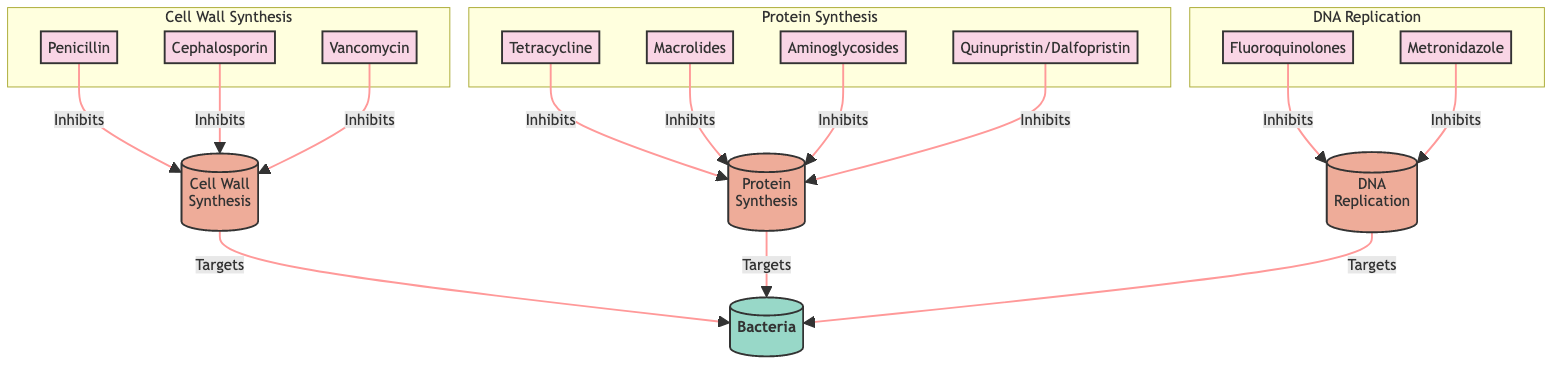What are the three main mechanisms of action illustrated in the diagram? The diagram displays three main mechanisms of action: Cell Wall Synthesis, Protein Synthesis, and DNA Replication. These are clearly labeled as subgraphs in the flowchart.
Answer: Cell Wall Synthesis, Protein Synthesis, DNA Replication How many antibiotics are associated with the Cell Wall Synthesis mechanism? The diagram shows three antibiotics related to Cell Wall Synthesis: Penicillin, Cephalosporin, and Vancomycin. Count the nodes connected to the Cell Wall Synthesis target to determine this.
Answer: 3 Which antibiotic inhibits Protein Synthesis and is also classified as an aminoglycoside? The diagram indicates that Aminoglycosides are part of the Protein Synthesis subgraph, identifying them as a specific antibiotic class. Among these antibiotics, their specific name is found attached to the Protein Synthesis target.
Answer: Aminoglycosides Which two antibiotics inhibit DNA Replication? From the diagram, Fluoroquinolones and Metronidazole are specifically linked to the DNA Replication mechanism, indicated clearly in their respective subgraph.
Answer: Fluoroquinolones, Metronidazole What is the relationship between all the antibiotics and the target "Bacteria"? The diagram shows that all antibiotics have arrows indicating they "Inhibit" specific cellular processes targeting "Bacteria." By observing the connections, we can summarize their collective role in combating bacteria.
Answer: Targets "Bacteria" 